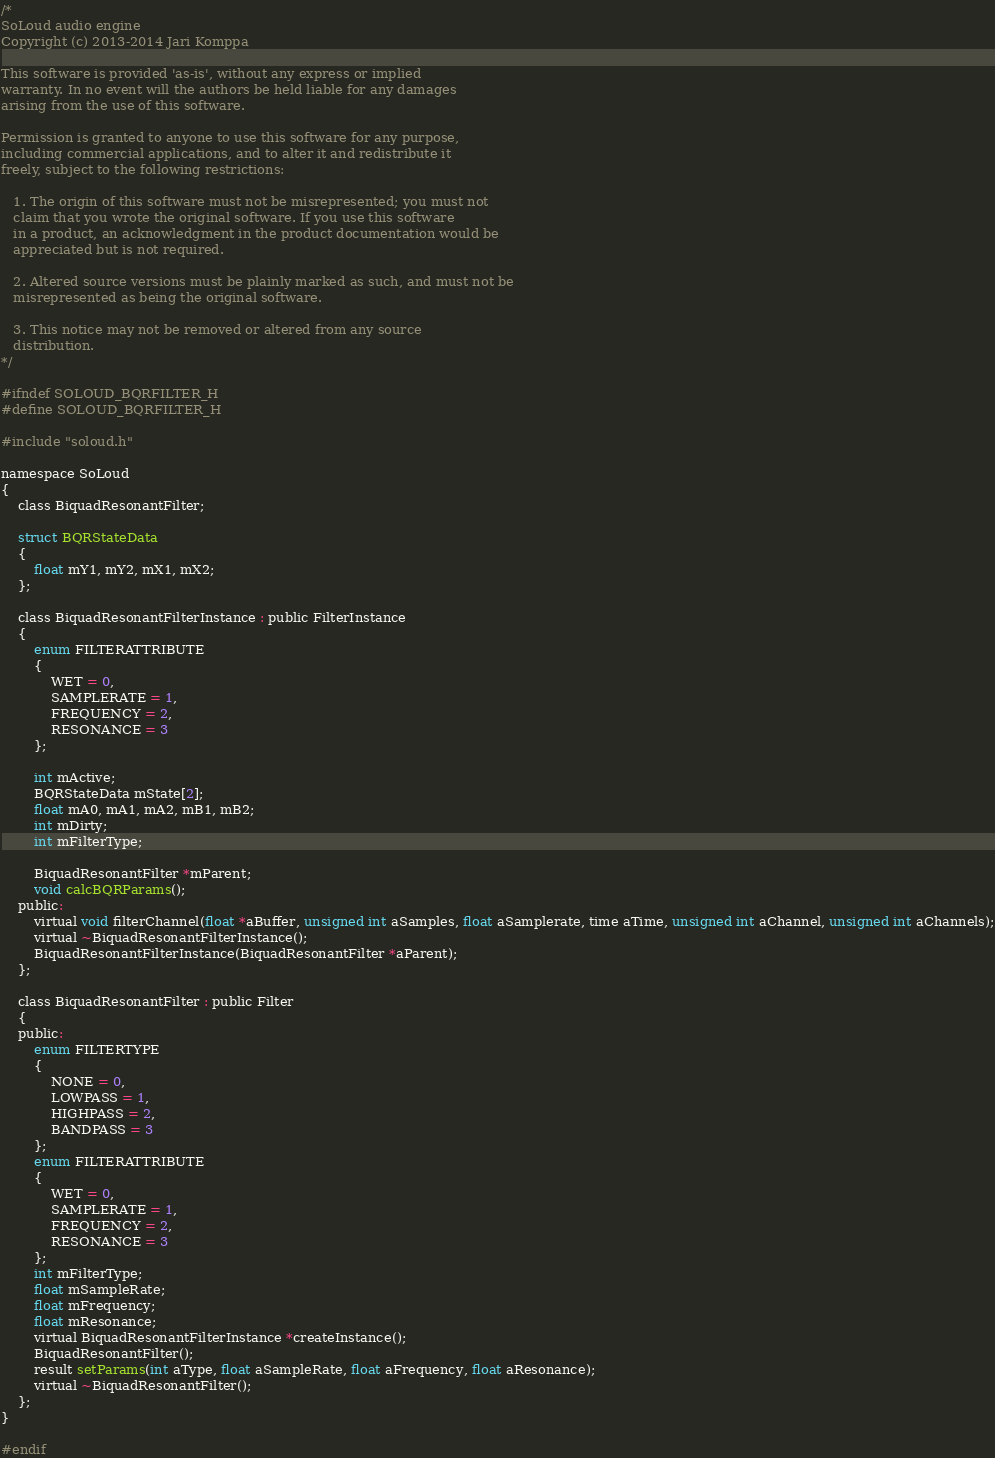Convert code to text. <code><loc_0><loc_0><loc_500><loc_500><_C_>/*
SoLoud audio engine
Copyright (c) 2013-2014 Jari Komppa

This software is provided 'as-is', without any express or implied
warranty. In no event will the authors be held liable for any damages
arising from the use of this software.

Permission is granted to anyone to use this software for any purpose,
including commercial applications, and to alter it and redistribute it
freely, subject to the following restrictions:

   1. The origin of this software must not be misrepresented; you must not
   claim that you wrote the original software. If you use this software
   in a product, an acknowledgment in the product documentation would be
   appreciated but is not required.

   2. Altered source versions must be plainly marked as such, and must not be
   misrepresented as being the original software.

   3. This notice may not be removed or altered from any source
   distribution.
*/

#ifndef SOLOUD_BQRFILTER_H
#define SOLOUD_BQRFILTER_H

#include "soloud.h"

namespace SoLoud
{
	class BiquadResonantFilter;

	struct BQRStateData
	{
		float mY1, mY2, mX1, mX2;
	};

	class BiquadResonantFilterInstance : public FilterInstance
	{
		enum FILTERATTRIBUTE
		{
			WET = 0,
			SAMPLERATE = 1,
			FREQUENCY = 2,
			RESONANCE = 3
		};

		int mActive;
		BQRStateData mState[2];
		float mA0, mA1, mA2, mB1, mB2;
		int mDirty;
		int mFilterType;

		BiquadResonantFilter *mParent;
		void calcBQRParams();
	public:
		virtual void filterChannel(float *aBuffer, unsigned int aSamples, float aSamplerate, time aTime, unsigned int aChannel, unsigned int aChannels);
		virtual ~BiquadResonantFilterInstance();
		BiquadResonantFilterInstance(BiquadResonantFilter *aParent);
	};

	class BiquadResonantFilter : public Filter
	{
	public:
		enum FILTERTYPE
		{
			NONE = 0,
			LOWPASS = 1,
			HIGHPASS = 2,
			BANDPASS = 3
		};
		enum FILTERATTRIBUTE
		{
			WET = 0,
			SAMPLERATE = 1,
			FREQUENCY = 2,
			RESONANCE = 3
		};
		int mFilterType;
		float mSampleRate;
		float mFrequency;
		float mResonance;
		virtual BiquadResonantFilterInstance *createInstance();
		BiquadResonantFilter();
		result setParams(int aType, float aSampleRate, float aFrequency, float aResonance);
		virtual ~BiquadResonantFilter();
	};
}

#endif</code> 